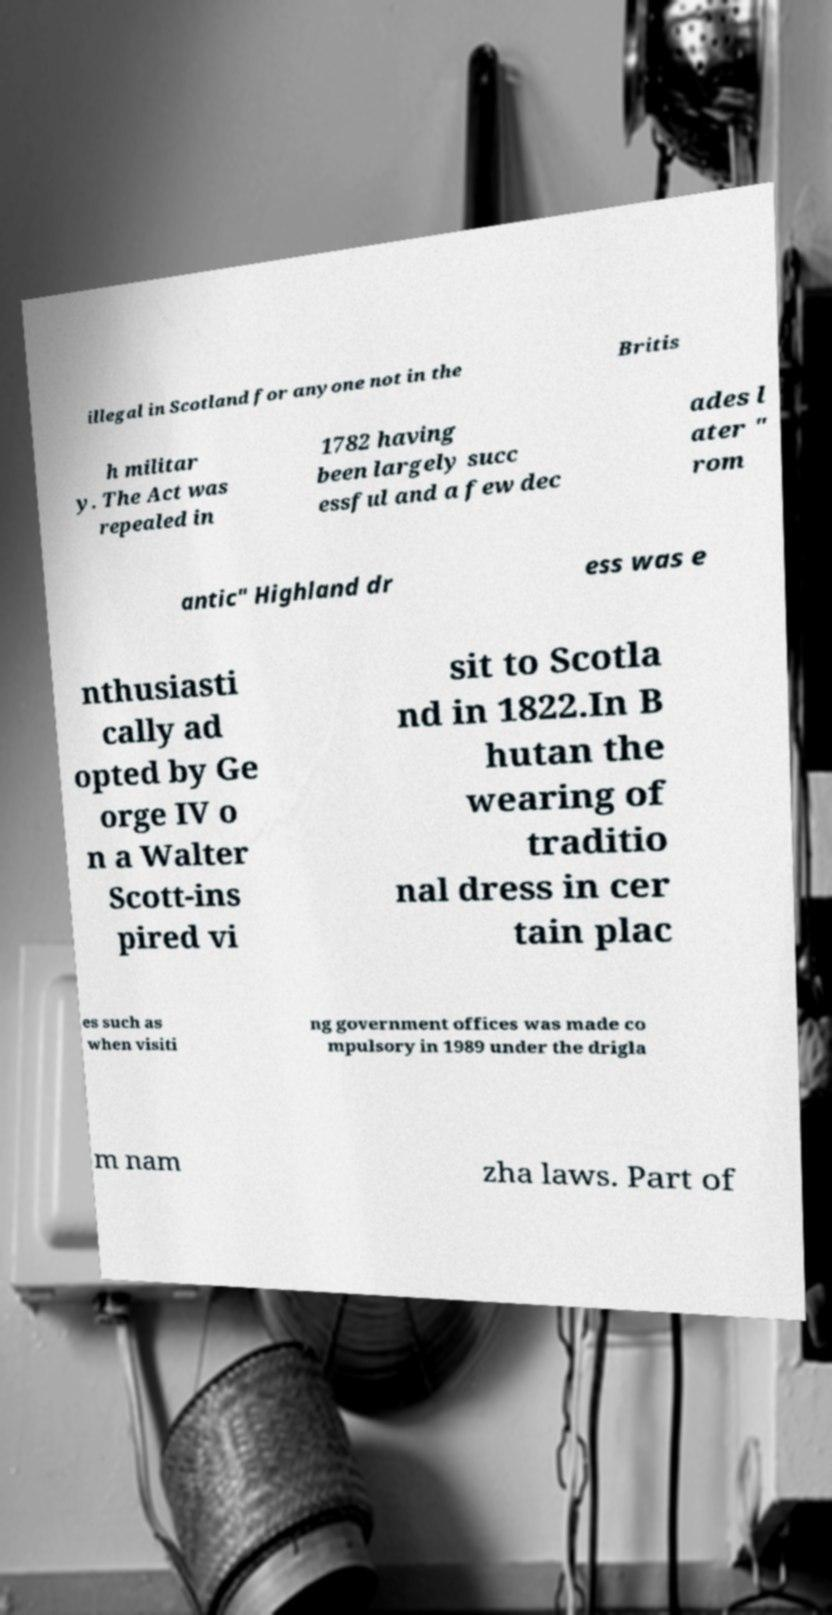What messages or text are displayed in this image? I need them in a readable, typed format. illegal in Scotland for anyone not in the Britis h militar y. The Act was repealed in 1782 having been largely succ essful and a few dec ades l ater " rom antic" Highland dr ess was e nthusiasti cally ad opted by Ge orge IV o n a Walter Scott-ins pired vi sit to Scotla nd in 1822.In B hutan the wearing of traditio nal dress in cer tain plac es such as when visiti ng government offices was made co mpulsory in 1989 under the drigla m nam zha laws. Part of 